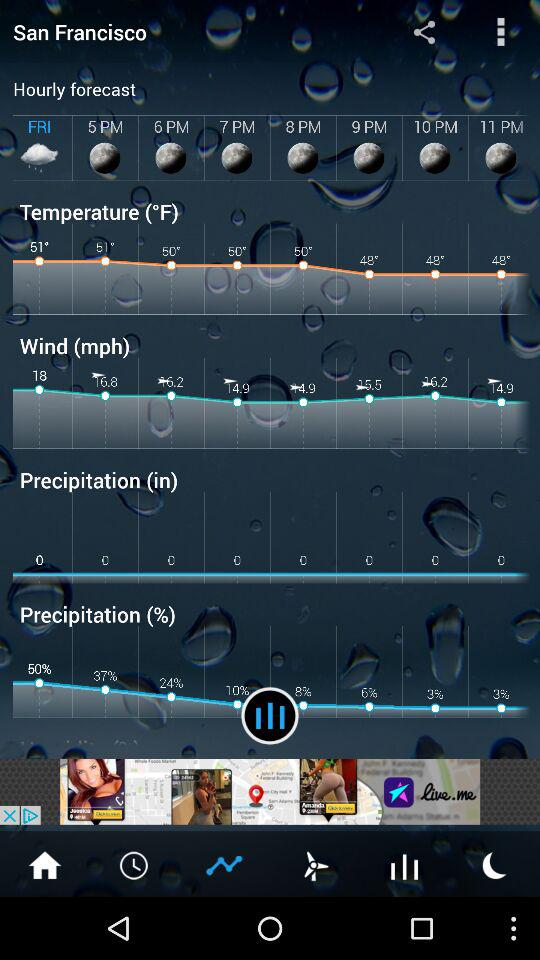What is the temperature at 5 PM? The temperature is 51° at 5 p.m. 